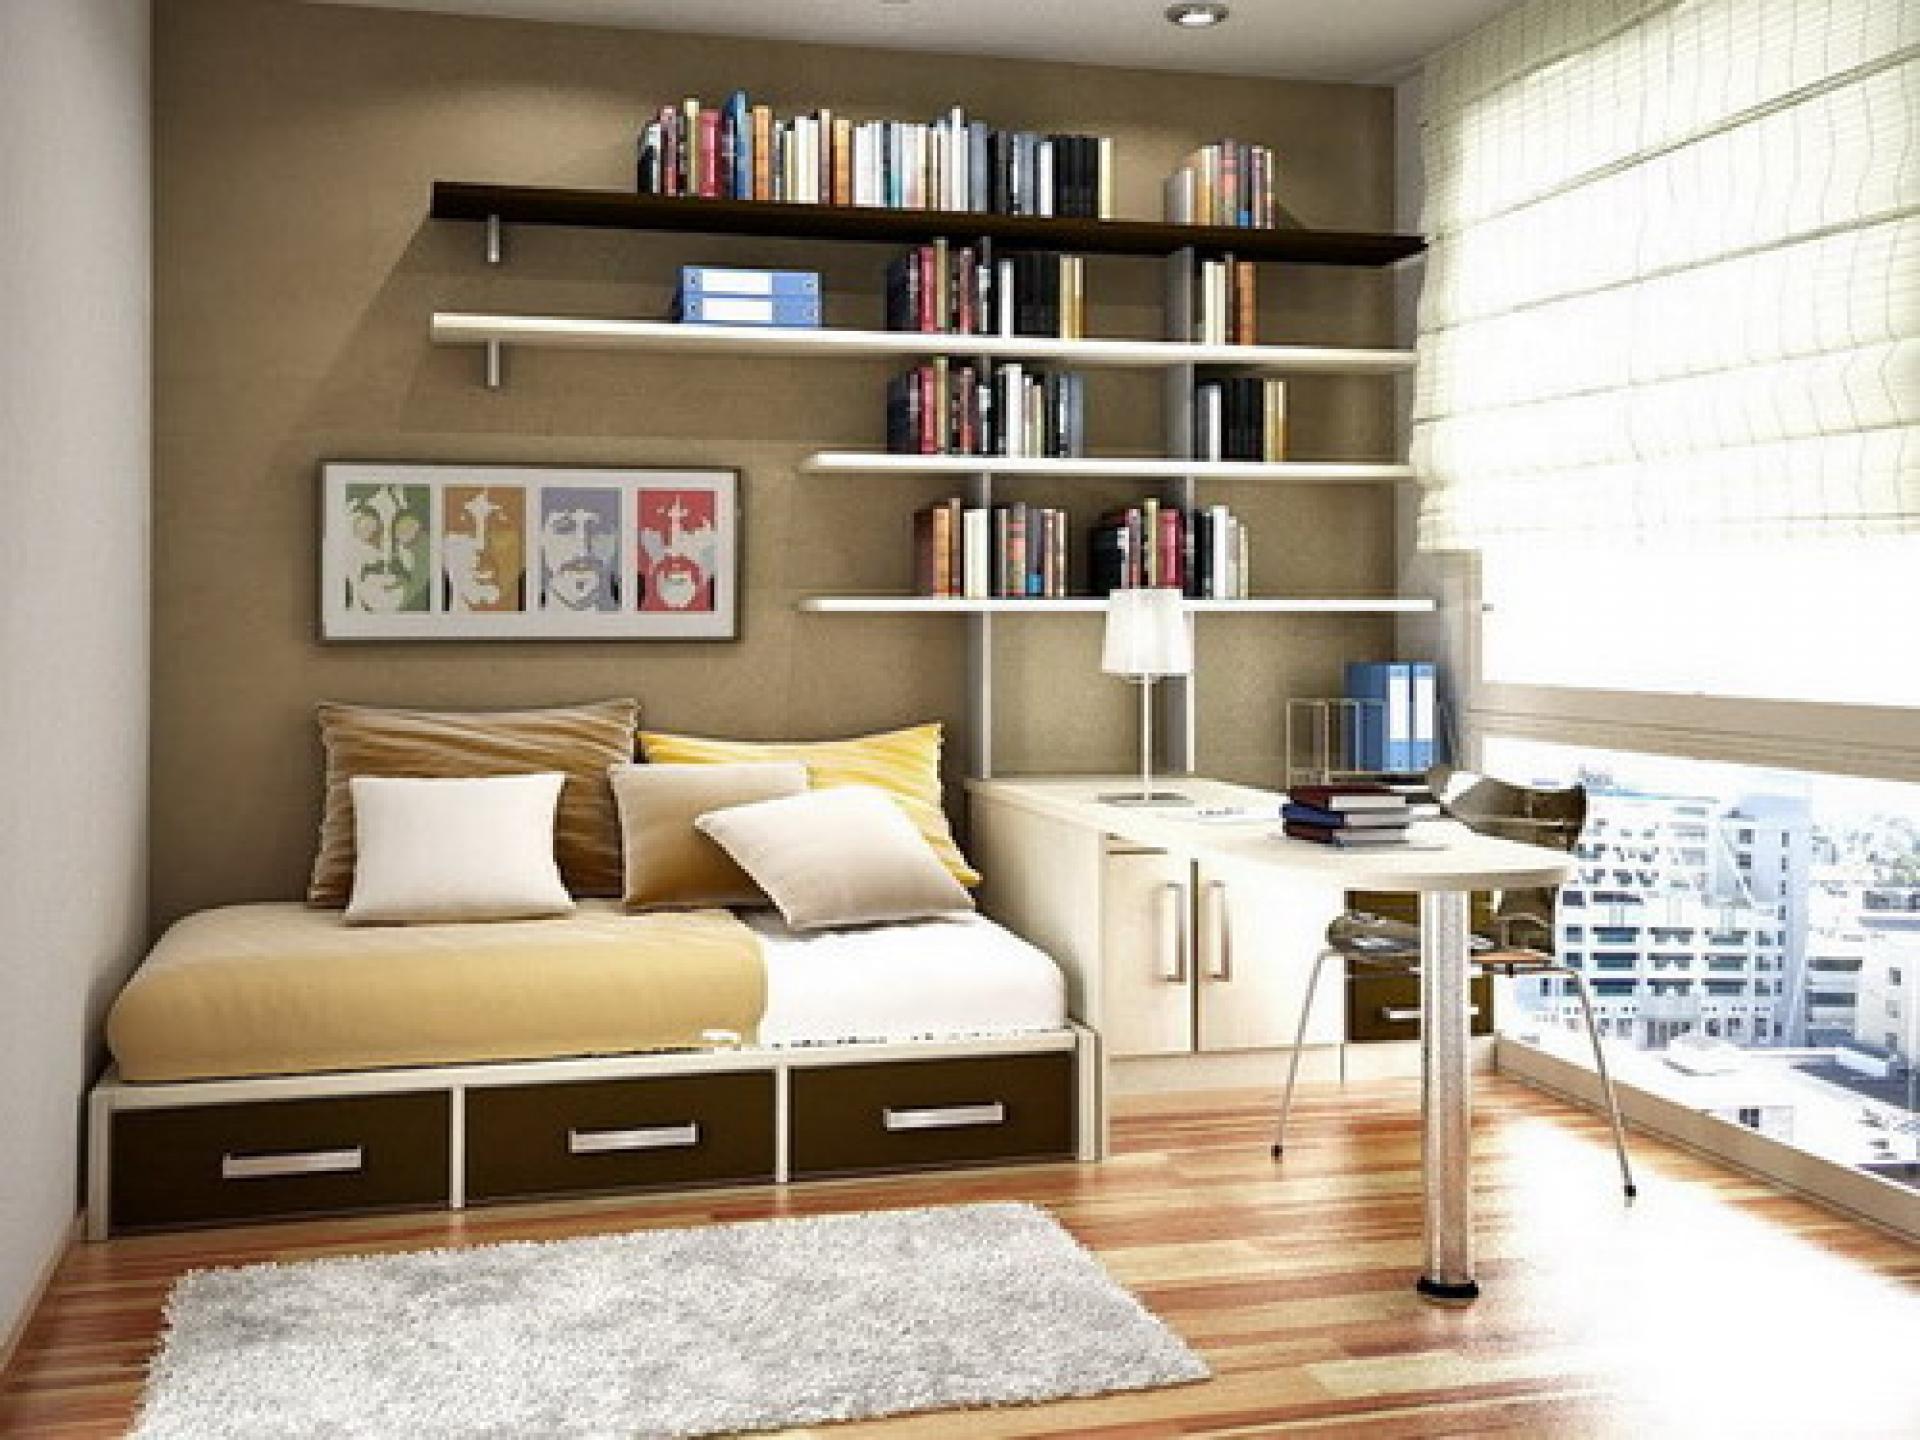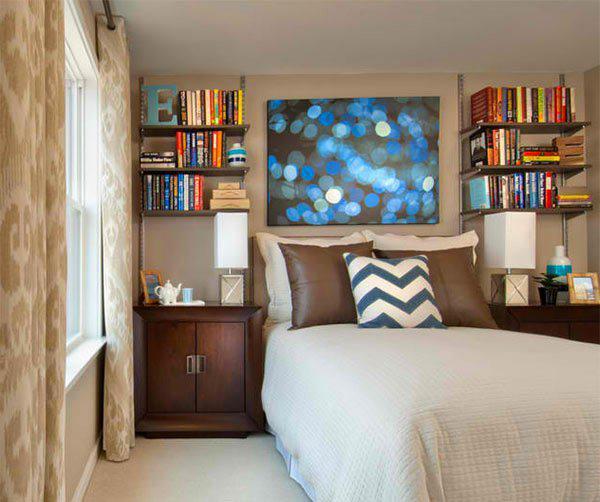The first image is the image on the left, the second image is the image on the right. Examine the images to the left and right. Is the description "A rug sits on the floor in the image on the left." accurate? Answer yes or no. Yes. The first image is the image on the left, the second image is the image on the right. Examine the images to the left and right. Is the description "A room has a platform bed with storage drawers underneath, and floating shelves on the wall behind it." accurate? Answer yes or no. Yes. 